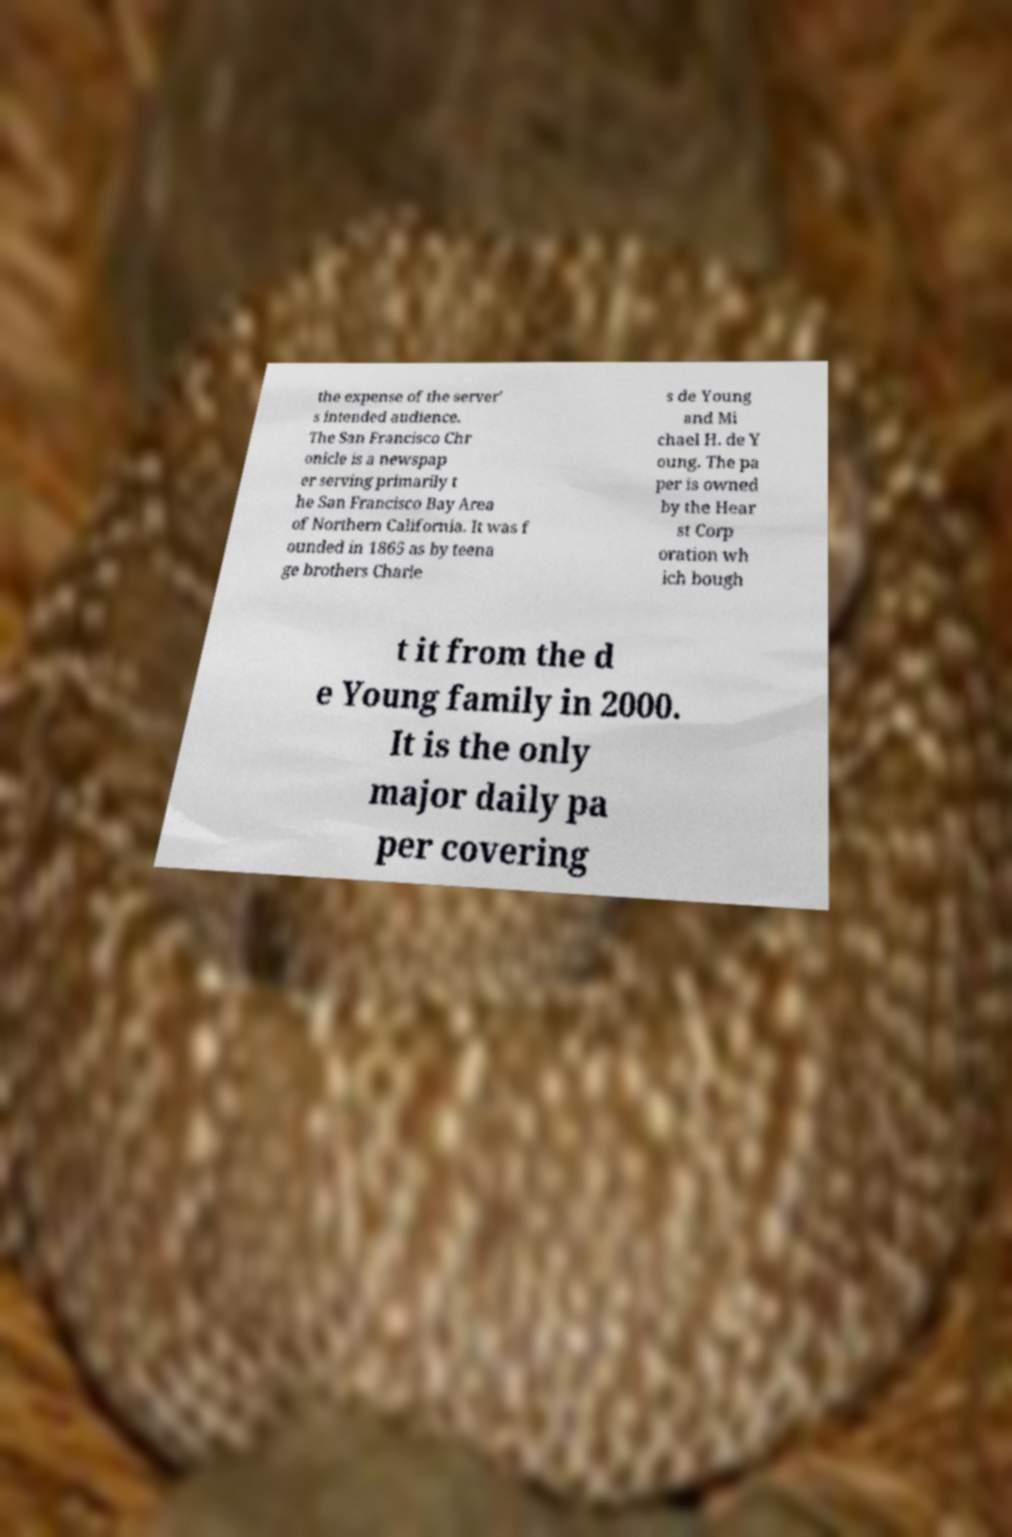Please read and relay the text visible in this image. What does it say? the expense of the server' s intended audience. The San Francisco Chr onicle is a newspap er serving primarily t he San Francisco Bay Area of Northern California. It was f ounded in 1865 as by teena ge brothers Charle s de Young and Mi chael H. de Y oung. The pa per is owned by the Hear st Corp oration wh ich bough t it from the d e Young family in 2000. It is the only major daily pa per covering 